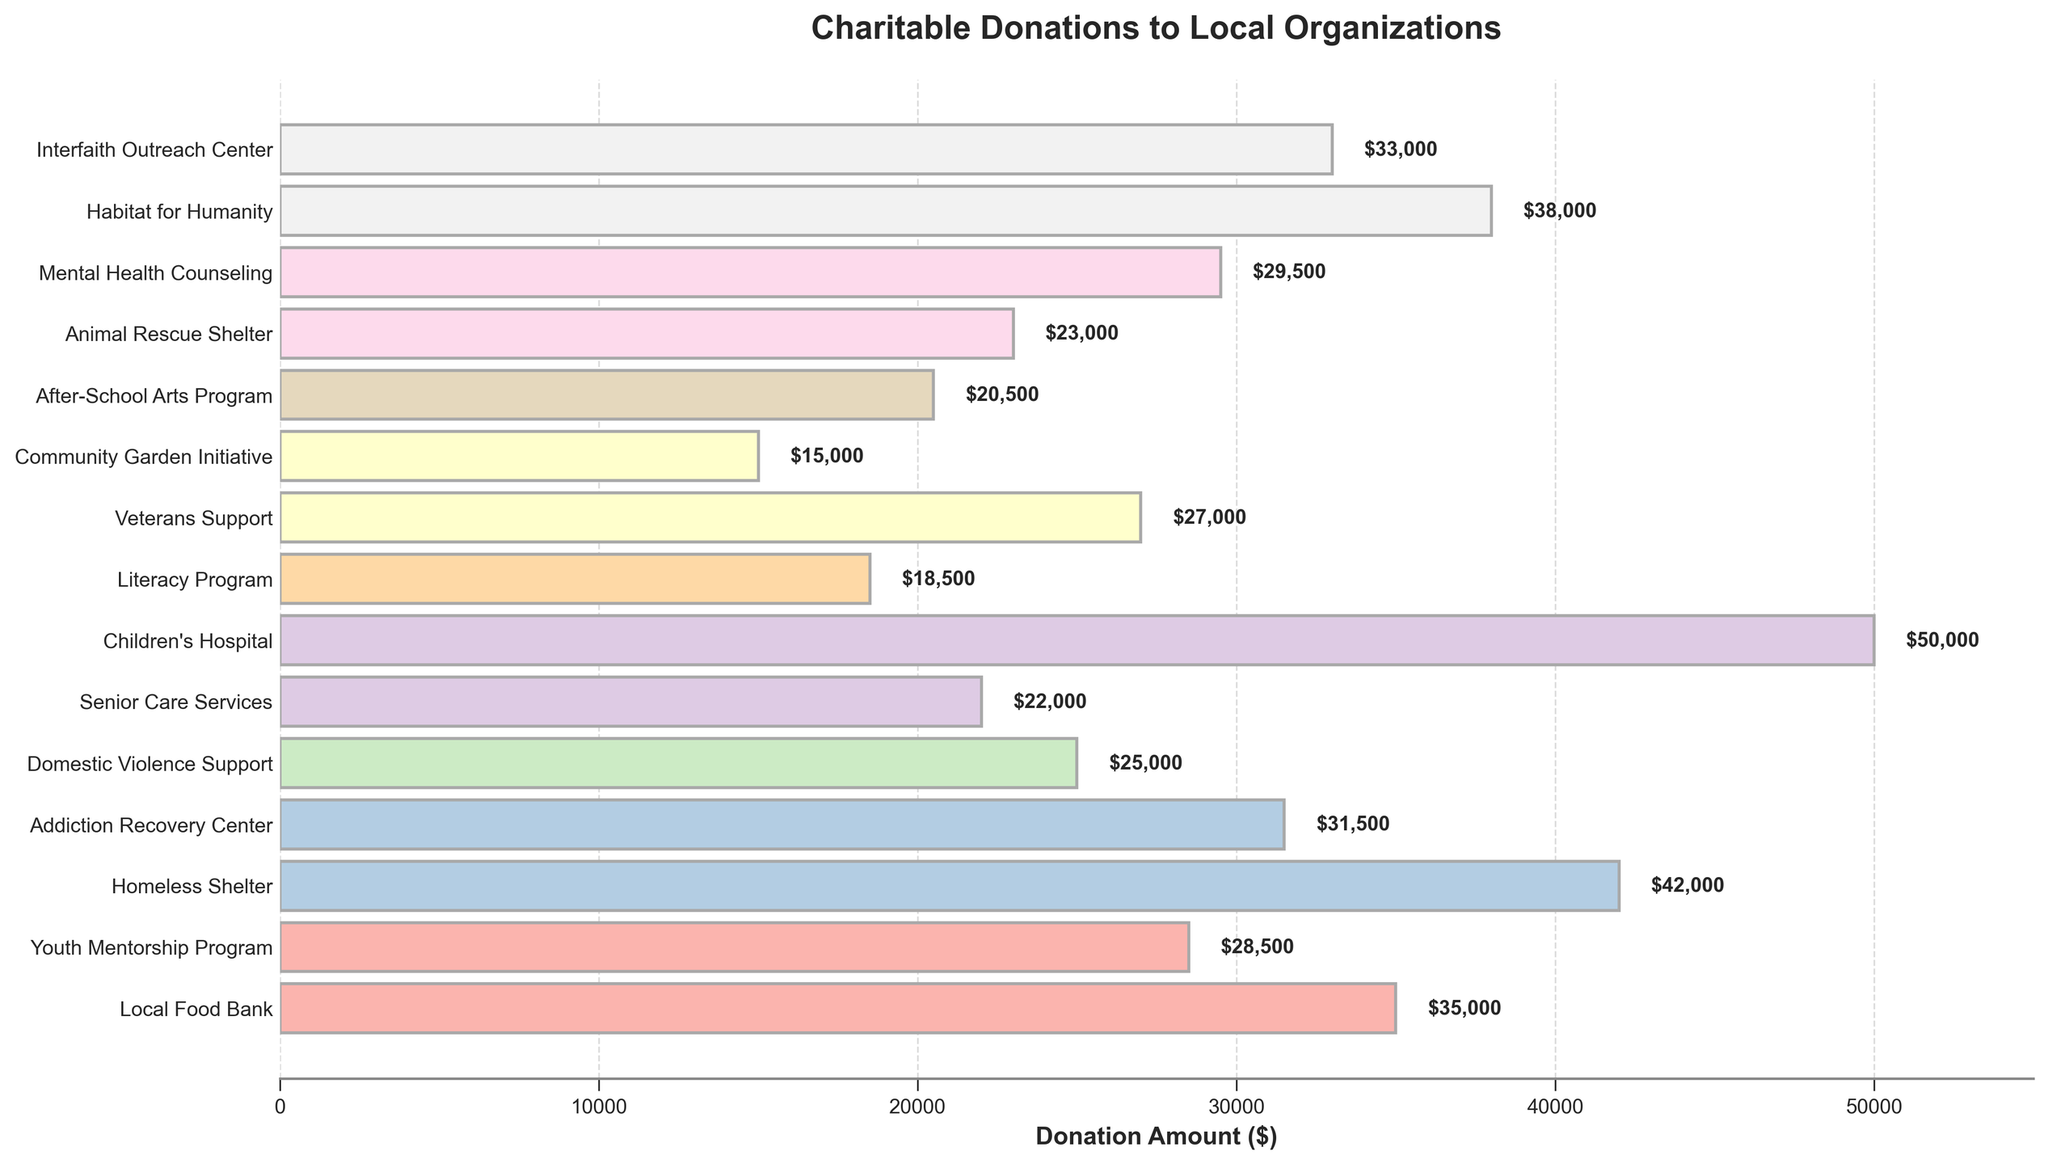Which charity received the highest donation amount? Observing the chart, the bar representing the Children's Hospital is the longest, indicating the highest donation amount of $50,000
Answer: Children's Hospital Which two organizations received the least donations combined? The bars for Community Garden Initiative ($15,000) and Literacy Program ($18,500) are the shortest. Their combined donations amount to $15,000 + $18,500 = $33,500
Answer: Community Garden Initiative and Literacy Program How much more did the Homeless Shelter receive compared to the Domestic Violence Support? The donation amount for the Homeless Shelter is $42,000, and for Domestic Violence Support, it's $25,000. Subtracting these, $42,000 - $25,000 = $17,000
Answer: $17,000 Which charities received donations between $30,000 and $40,000? Observing the chart, the charities in this range are Addiction Recovery Center ($31,500), Habitat for Humanity ($38,000), and Interfaith Outreach Center ($33,000)
Answer: Addiction Recovery Center, Habitat for Humanity, Interfaith Outreach Center What is the total donation amount for Youth Mentorship Program and Mental Health Counseling combined? Youth Mentorship Program received $28,500, and Mental Health Counseling received $29,500. Adding these amounts, $28,500 + $29,500 = $58,000
Answer: $58,000 By how much does the sum of donations to the top five charities exceed the sum of donations to the bottom five charities? The top five charities are Children's Hospital ($50,000), Homeless Shelter ($42,000), Habitat for Humanity ($38,000), Interfaith Outreach Center ($33,000), and Local Food Bank ($35,000). Their sum is $198,000. The bottom five charities are Community Garden Initiative ($15,000), Literacy Program ($18,500), After-School Arts Program ($20,500), Senior Care Services ($22,000), and Animal Rescue Shelter ($23,000). Their sum is $99,000. The difference is $198,000 - $99,000 = $99,000
Answer: $99,000 Which charity type has a donation amount closest to the middle value? Sorting all donation amounts, the median value is around the 8th and 9th values: ($28,500 and $29,500), averaging $29,000. The Mental Health Counseling received $29,500, which is closest to this median
Answer: Mental Health Counseling What is the average donation amount across all charities? Sum all donation amounts: $35,000 + $28,500 + $42,000 + $31,500 + $25,000 + $22,000 + $50,000 + $18,500 + $27,000 + $15,000 + $20,500 + $23,000 + $29,500 + $38,000 + $33,000 = $439,500. Divide by the number of charities (15), $439,500 / 15 = $29,300
Answer: $29,300 Which charity received exactly twice as much as the Senior Care Services? The Senior Care Services received $22,000. Looking for a donation amount of $22,000 * 2 = $44,000. No charity received exactly this amount, so the answer is none
Answer: None Which is longer: the bar for Veterans Support or the bar for Youth Mentorship Program? Comparing the lengths, the donation for Veterans Support is $27,000, while for Youth Mentorship Program, it's $28,500. The bar for Youth Mentorship Program is longer
Answer: Youth Mentorship Program 